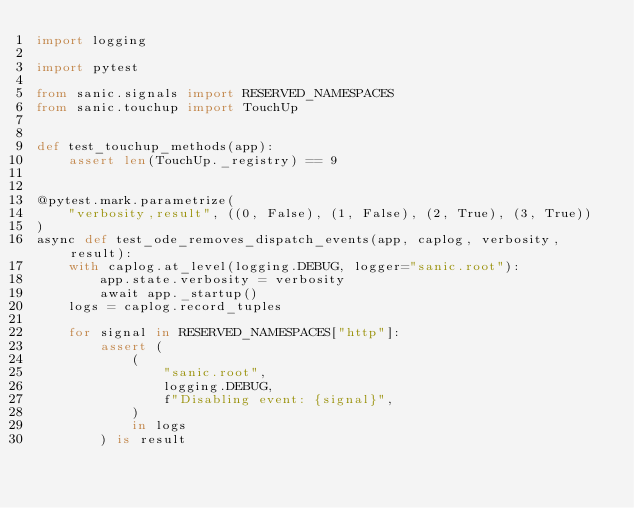Convert code to text. <code><loc_0><loc_0><loc_500><loc_500><_Python_>import logging

import pytest

from sanic.signals import RESERVED_NAMESPACES
from sanic.touchup import TouchUp


def test_touchup_methods(app):
    assert len(TouchUp._registry) == 9


@pytest.mark.parametrize(
    "verbosity,result", ((0, False), (1, False), (2, True), (3, True))
)
async def test_ode_removes_dispatch_events(app, caplog, verbosity, result):
    with caplog.at_level(logging.DEBUG, logger="sanic.root"):
        app.state.verbosity = verbosity
        await app._startup()
    logs = caplog.record_tuples

    for signal in RESERVED_NAMESPACES["http"]:
        assert (
            (
                "sanic.root",
                logging.DEBUG,
                f"Disabling event: {signal}",
            )
            in logs
        ) is result
</code> 